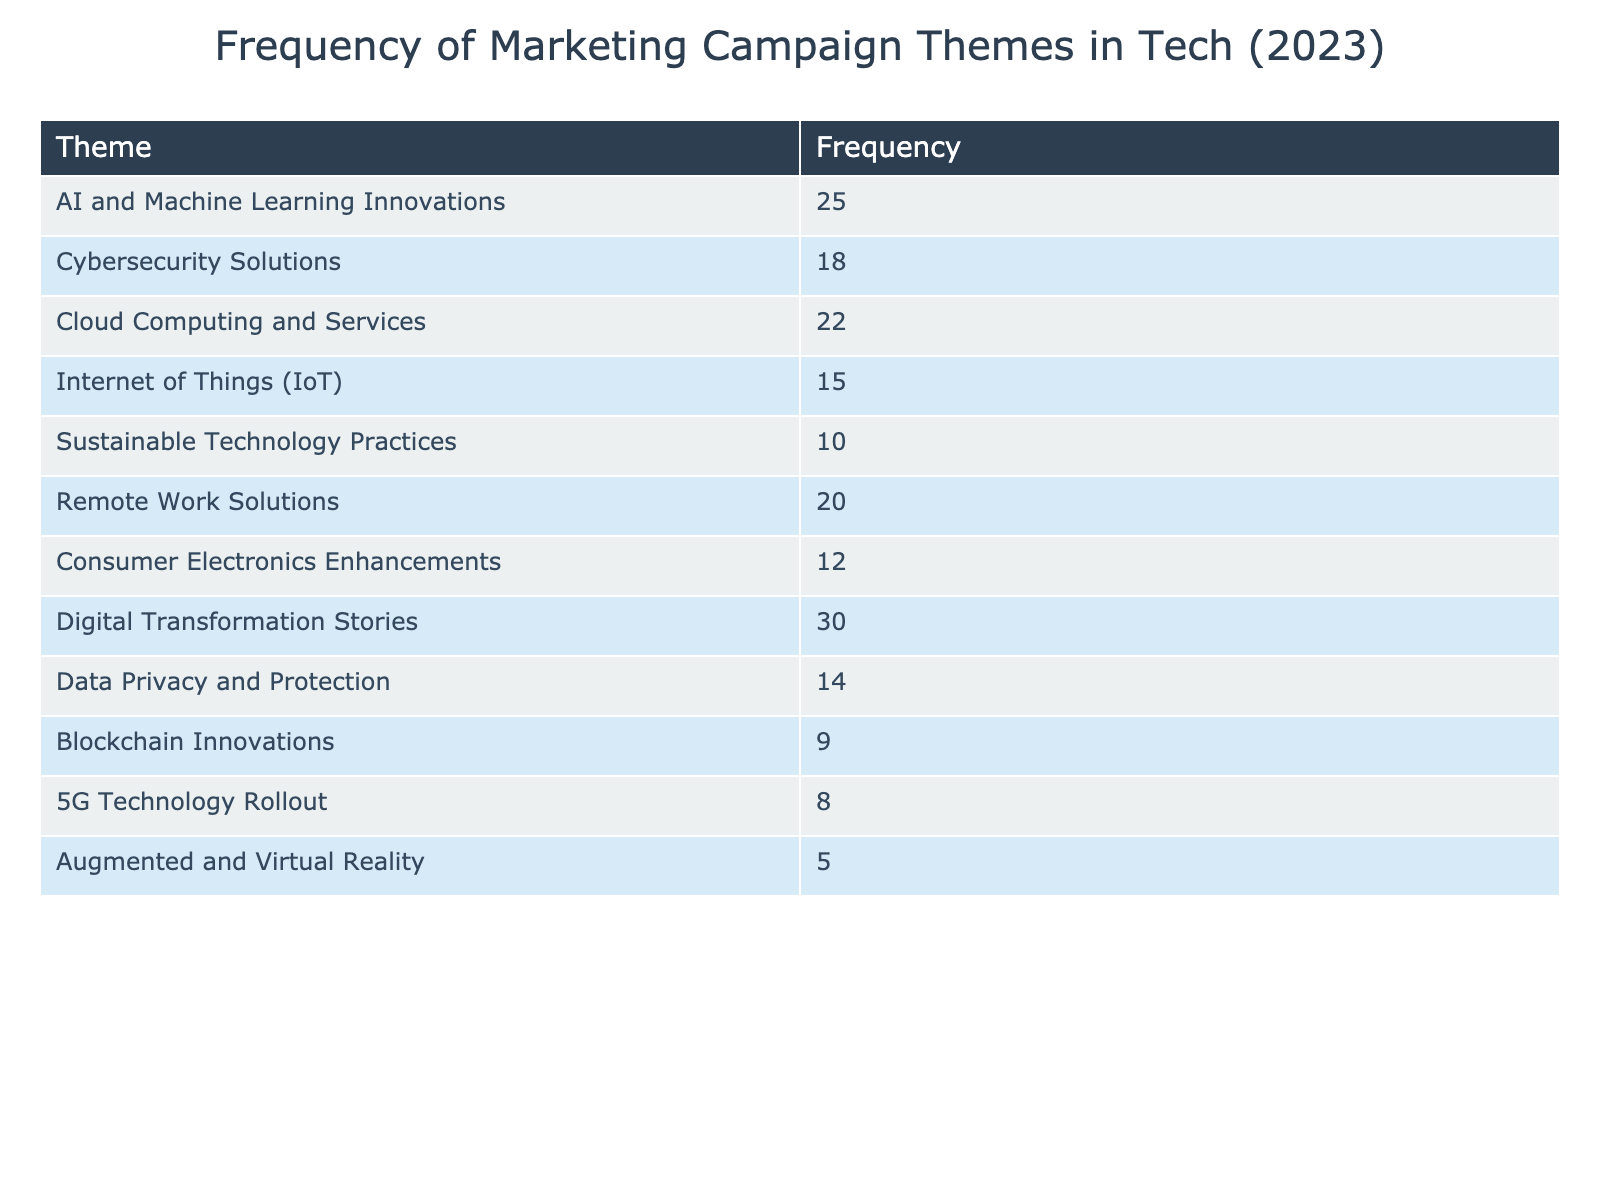What is the frequency of the "Digital Transformation Stories" theme? The table specifically lists the frequency for each theme, and for "Digital Transformation Stories," the corresponding frequency value is directly shown in the table as 30.
Answer: 30 Which theme has the lowest frequency? By examining the table, I see that "Augmented and Virtual Reality" has the lowest frequency value at 5, as all other themes have higher values.
Answer: Augmented and Virtual Reality What is the total frequency of all themes combined? To find the total frequency, I need to sum all the individual frequency values: 25 + 18 + 22 + 15 + 10 + 20 + 12 + 30 + 14 + 9 + 8 + 5 =  25 + 18 + 22 + 15 + 10 + 20 + 12 + 30 + 14 + 9 + 8 + 5 =  30 + 50 + 20 + 25 +  31 + 9 =  130.
Answer: 130 Is the frequency of "Cybersecurity Solutions" greater than that of "Blockchain Innovations"? The frequency for "Cybersecurity Solutions" is 18 and for "Blockchain Innovations" it is 9, confirming that 18 is indeed greater than 9.
Answer: Yes What is the average frequency of the themes related to technology innovations (AI and Machine Learning Innovations, Cloud Computing and Services, Blockchain Innovations, and Cybersecurity Solutions)? First, I identify the frequency values for these four themes: AI and Machine Learning Innovations (25), Cloud Computing and Services (22), Blockchain Innovations (9), and Cybersecurity Solutions (18). Next, I sum these values: 25 + 22 + 9 + 18 = 74, and since there are 4 themes, I divide the sum by 4 to find the average: 74 / 4 = 18.5.
Answer: 18.5 How many themes have a frequency greater than 15? Looking through the table, I count the themes with frequencies greater than 15: "AI and Machine Learning Innovations" (25), "Cloud Computing and Services" (22), "Remote Work Solutions" (20), "Digital Transformation Stories" (30). There are 4 themes meeting this criterion.
Answer: 4 What is the difference in frequency between the most and least frequent themes? The most frequent theme is "Digital Transformation Stories" with a frequency of 30, while the least frequent theme is "Augmented and Virtual Reality" with a frequency of 5. The difference is calculated as 30 - 5 = 25.
Answer: 25 Are there more themes focusing on emerging technologies than traditional ones? The table lists 7 themes related to emerging technologies (AI, Cloud Computing, IoT, Cybersecurity, Remote Work, Blockchain, and AR/VR) and 5 traditional ones (Sustainable Practices, Consumer Electronics Enhancements, Digital Transformation, Data Privacy). Hence, there are more themes focusing on emerging technologies.
Answer: Yes Which theme had a frequency count between 10 and 20? To answer this, I examine each theme's frequency: "Sustainable Technology Practices" (10), "Consumer Electronics Enhancements" (12), "Data Privacy and Protection" (14), "Internet of Things (IoT)" (15), and "Cybersecurity Solutions" (18) all fall between 10 and 20.
Answer: 4 